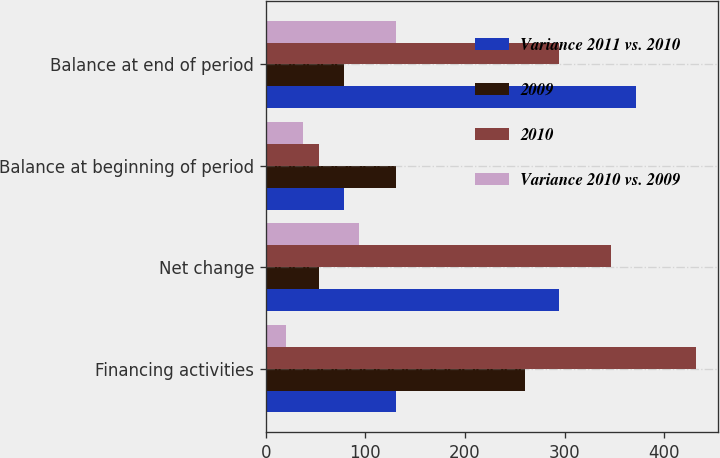<chart> <loc_0><loc_0><loc_500><loc_500><stacked_bar_chart><ecel><fcel>Financing activities<fcel>Net change<fcel>Balance at beginning of period<fcel>Balance at end of period<nl><fcel>Variance 2011 vs. 2010<fcel>131<fcel>294<fcel>78<fcel>372<nl><fcel>2009<fcel>260<fcel>53<fcel>131<fcel>78<nl><fcel>2010<fcel>432<fcel>347<fcel>53<fcel>294<nl><fcel>Variance 2010 vs. 2009<fcel>20<fcel>94<fcel>37<fcel>131<nl></chart> 